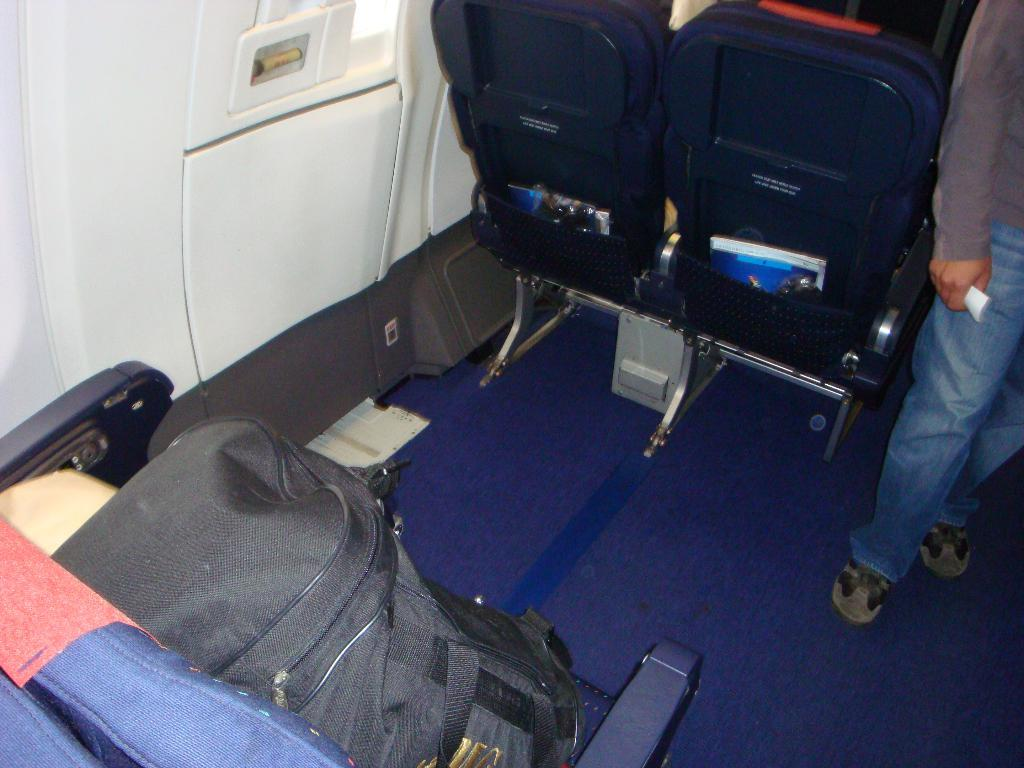What type of setting is depicted in the image? The image shows an inside view of a vehicle. What can be seen on the chair in the image? There is a luggage bag on a chair. Is there anyone else in the image besides the luggage bag? Yes, there is a person standing near the chairs. What type of leaf can be seen hanging from the wire in the image? There is no leaf or wire present in the image; it shows an inside view of a vehicle with a luggage bag on a chair and a person standing nearby. 